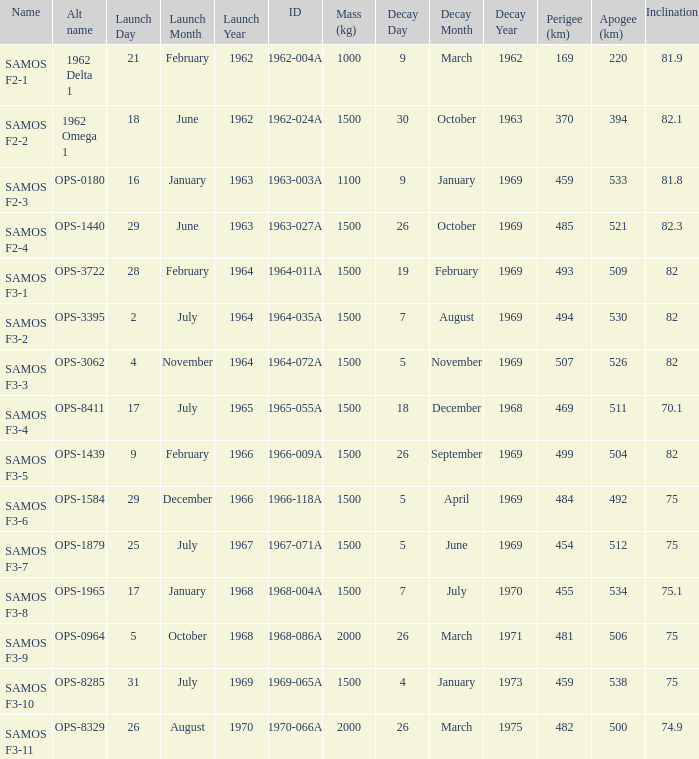What was the maximum perigee on 1969-01-09? 459.0. 